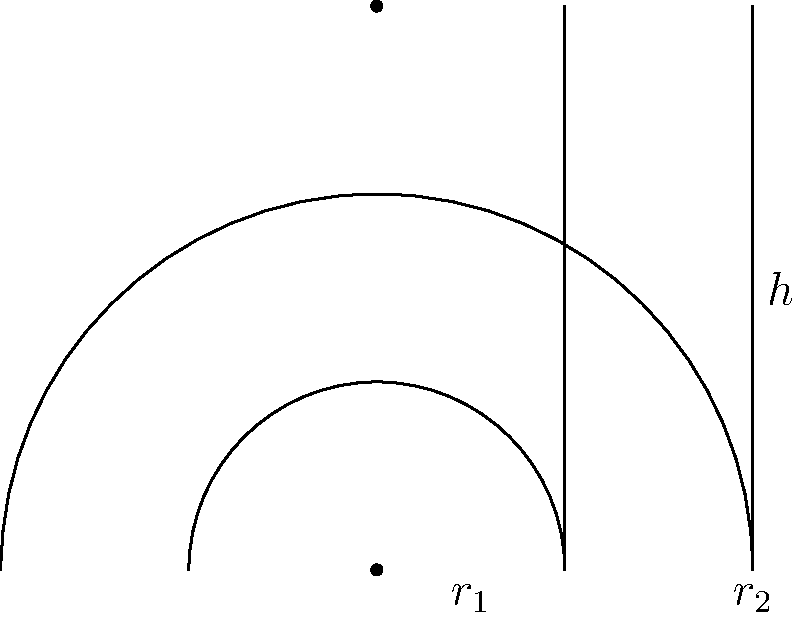In our local cinema, we're examining two film reels of different sizes. The smaller reel has a radius $r_1 = 5$ cm, while the larger reel has a radius $r_2 = 10$ cm. Both reels have a height $h = 15$ cm. If the film thickness is 0.1 mm and each frame occupies 2 cm of film length, how many more minutes of movie time can the larger reel hold compared to the smaller one? Assume the film projector runs at 24 frames per second. Let's approach this step-by-step:

1) First, we need to calculate the volume of film each reel can hold. The volume is the difference between the outer and inner cylinders:

   $V = \pi h (r_2^2 - r_1^2)$

2) For the smaller reel: 
   $V_1 = \pi \cdot 15 \cdot (5^2 - 0^2) = 1178.10$ cm³

3) For the larger reel:
   $V_2 = \pi \cdot 15 \cdot (10^2 - 5^2) = 3534.29$ cm³

4) The difference in volume: 
   $\Delta V = V_2 - V_1 = 2356.19$ cm³

5) Given the film thickness of 0.1 mm = 0.01 cm, we can calculate the total length of film:

   $L = \Delta V / (0.01 \cdot h) = 2356.19 / (0.01 \cdot 15) = 15707.96$ cm

6) Each frame occupies 2 cm, so the number of frames is:

   $N_{frames} = 15707.96 / 2 = 7853.98$ frames

7) At 24 frames per second, the additional runtime in seconds is:

   $T = 7853.98 / 24 = 327.25$ seconds

8) Converting to minutes:

   $T_{minutes} = 327.25 / 60 = 5.45$ minutes

Therefore, the larger reel can hold approximately 5.45 more minutes of movie time.
Answer: 5.45 minutes 